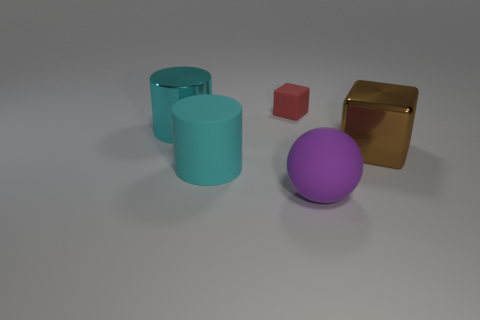Is there any other thing that is the same size as the red cube?
Make the answer very short. No. What shape is the rubber object that is in front of the red block and behind the large sphere?
Offer a very short reply. Cylinder. What number of other things are there of the same shape as the big cyan rubber object?
Provide a short and direct response. 1. There is a shiny cube that is the same size as the cyan rubber cylinder; what is its color?
Give a very brief answer. Brown. How many objects are cyan cylinders or metal cylinders?
Your answer should be compact. 2. Are there any large balls on the left side of the brown metallic cube?
Provide a succinct answer. Yes. Is there another purple object that has the same material as the small thing?
Your response must be concise. Yes. What number of blocks are large brown objects or small objects?
Ensure brevity in your answer.  2. Are there more big cyan rubber things in front of the cyan metallic object than metal cubes in front of the big brown shiny block?
Provide a short and direct response. Yes. What number of big cylinders are the same color as the metal cube?
Offer a terse response. 0. 